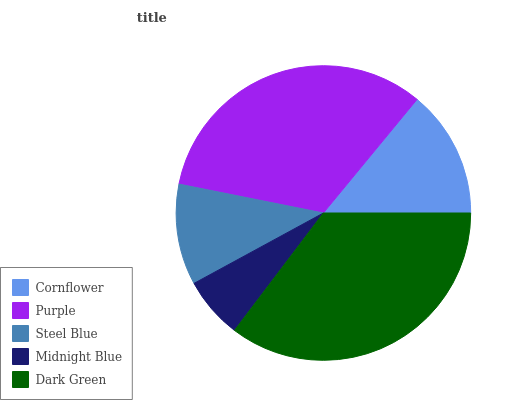Is Midnight Blue the minimum?
Answer yes or no. Yes. Is Dark Green the maximum?
Answer yes or no. Yes. Is Purple the minimum?
Answer yes or no. No. Is Purple the maximum?
Answer yes or no. No. Is Purple greater than Cornflower?
Answer yes or no. Yes. Is Cornflower less than Purple?
Answer yes or no. Yes. Is Cornflower greater than Purple?
Answer yes or no. No. Is Purple less than Cornflower?
Answer yes or no. No. Is Cornflower the high median?
Answer yes or no. Yes. Is Cornflower the low median?
Answer yes or no. Yes. Is Steel Blue the high median?
Answer yes or no. No. Is Steel Blue the low median?
Answer yes or no. No. 